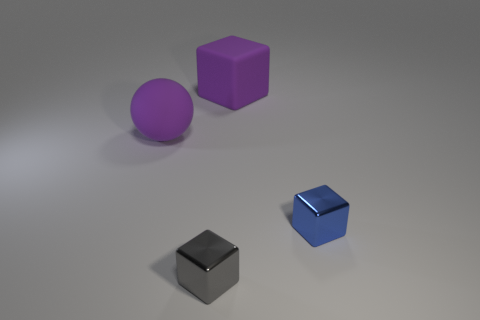Are there fewer large purple matte spheres than yellow cylinders?
Give a very brief answer. No. What is the shape of the purple thing on the right side of the tiny thing in front of the blue cube that is on the right side of the purple ball?
Your response must be concise. Cube. There is a big rubber thing that is the same color as the matte cube; what shape is it?
Ensure brevity in your answer.  Sphere. Are any cyan matte balls visible?
Offer a terse response. No. Do the matte ball and the shiny thing that is behind the gray thing have the same size?
Provide a succinct answer. No. There is a small metallic object that is on the left side of the blue cube; is there a small metal block in front of it?
Make the answer very short. No. There is a thing that is both behind the blue block and to the right of the big purple matte sphere; what material is it made of?
Offer a terse response. Rubber. What is the color of the small metal thing on the right side of the purple rubber thing that is right of the metal cube that is on the left side of the big purple block?
Offer a very short reply. Blue. The other block that is the same size as the gray metallic block is what color?
Your answer should be very brief. Blue. There is a large sphere; is its color the same as the big matte thing behind the big purple sphere?
Provide a succinct answer. Yes. 